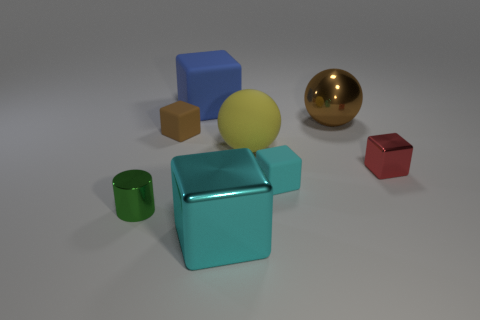Subtract all tiny brown blocks. How many blocks are left? 4 Subtract 3 cubes. How many cubes are left? 2 Subtract all brown spheres. How many spheres are left? 1 Add 2 brown metal balls. How many objects exist? 10 Subtract all cylinders. How many objects are left? 7 Subtract all gray cylinders. How many red cubes are left? 1 Add 6 small gray shiny things. How many small gray shiny things exist? 6 Subtract 1 brown blocks. How many objects are left? 7 Subtract all gray blocks. Subtract all red cylinders. How many blocks are left? 5 Subtract all purple rubber cubes. Subtract all big spheres. How many objects are left? 6 